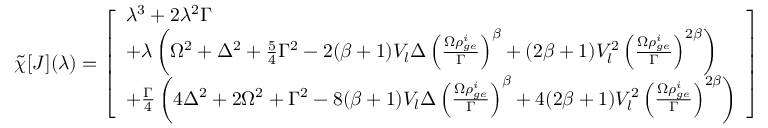Convert formula to latex. <formula><loc_0><loc_0><loc_500><loc_500>\tilde { \chi } [ J ] ( \lambda ) = \left [ \begin{array} { l } { \lambda ^ { 3 } + 2 \lambda ^ { 2 } \Gamma } \\ { + \lambda \left ( \Omega ^ { 2 } + \Delta ^ { 2 } + \frac { 5 } { 4 } \Gamma ^ { 2 } - 2 ( \beta + 1 ) V _ { l } \Delta \left ( \frac { \Omega \rho _ { g e } ^ { i } } { \Gamma } \right ) ^ { \beta } + ( 2 \beta + 1 ) V _ { l } ^ { 2 } \left ( \frac { \Omega \rho _ { g e } ^ { i } } { \Gamma } \right ) ^ { 2 \beta } \right ) } \\ { + \frac { \Gamma } { 4 } \left ( 4 \Delta ^ { 2 } + 2 \Omega ^ { 2 } + \Gamma ^ { 2 } - 8 ( \beta + 1 ) V _ { l } \Delta \left ( \frac { \Omega \rho _ { g e } ^ { i } } { \Gamma } \right ) ^ { \beta } + 4 ( 2 \beta + 1 ) V _ { l } ^ { 2 } \left ( \frac { \Omega \rho _ { g e } ^ { i } } { \Gamma } \right ) ^ { 2 \beta } \right ) } \end{array} \right ]</formula> 